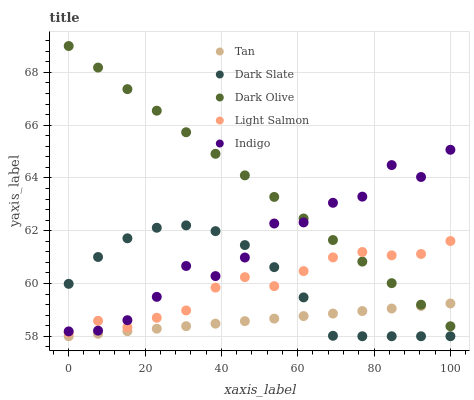Does Tan have the minimum area under the curve?
Answer yes or no. Yes. Does Dark Olive have the maximum area under the curve?
Answer yes or no. Yes. Does Dark Olive have the minimum area under the curve?
Answer yes or no. No. Does Tan have the maximum area under the curve?
Answer yes or no. No. Is Dark Olive the smoothest?
Answer yes or no. Yes. Is Indigo the roughest?
Answer yes or no. Yes. Is Tan the smoothest?
Answer yes or no. No. Is Tan the roughest?
Answer yes or no. No. Does Dark Slate have the lowest value?
Answer yes or no. Yes. Does Dark Olive have the lowest value?
Answer yes or no. No. Does Dark Olive have the highest value?
Answer yes or no. Yes. Does Tan have the highest value?
Answer yes or no. No. Is Dark Slate less than Dark Olive?
Answer yes or no. Yes. Is Dark Olive greater than Dark Slate?
Answer yes or no. Yes. Does Dark Olive intersect Light Salmon?
Answer yes or no. Yes. Is Dark Olive less than Light Salmon?
Answer yes or no. No. Is Dark Olive greater than Light Salmon?
Answer yes or no. No. Does Dark Slate intersect Dark Olive?
Answer yes or no. No. 